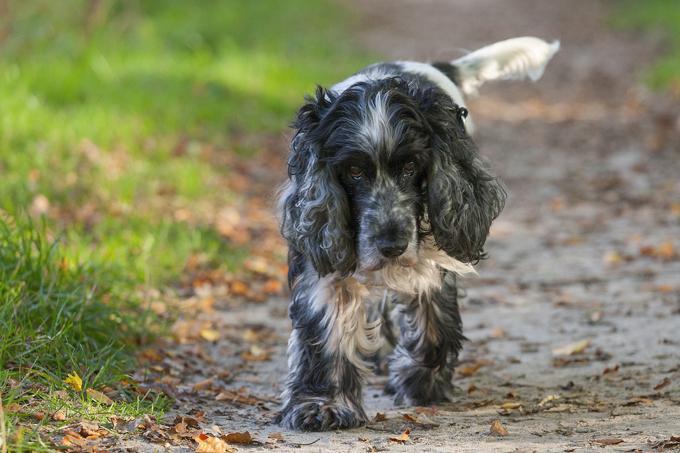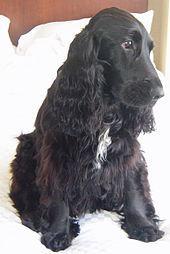The first image is the image on the left, the second image is the image on the right. Considering the images on both sides, is "A black-and-tan dog sits upright on the left of a golden haired dog that also sits upright." valid? Answer yes or no. No. The first image is the image on the left, the second image is the image on the right. Considering the images on both sides, is "The right image contains at least three dogs." valid? Answer yes or no. No. 